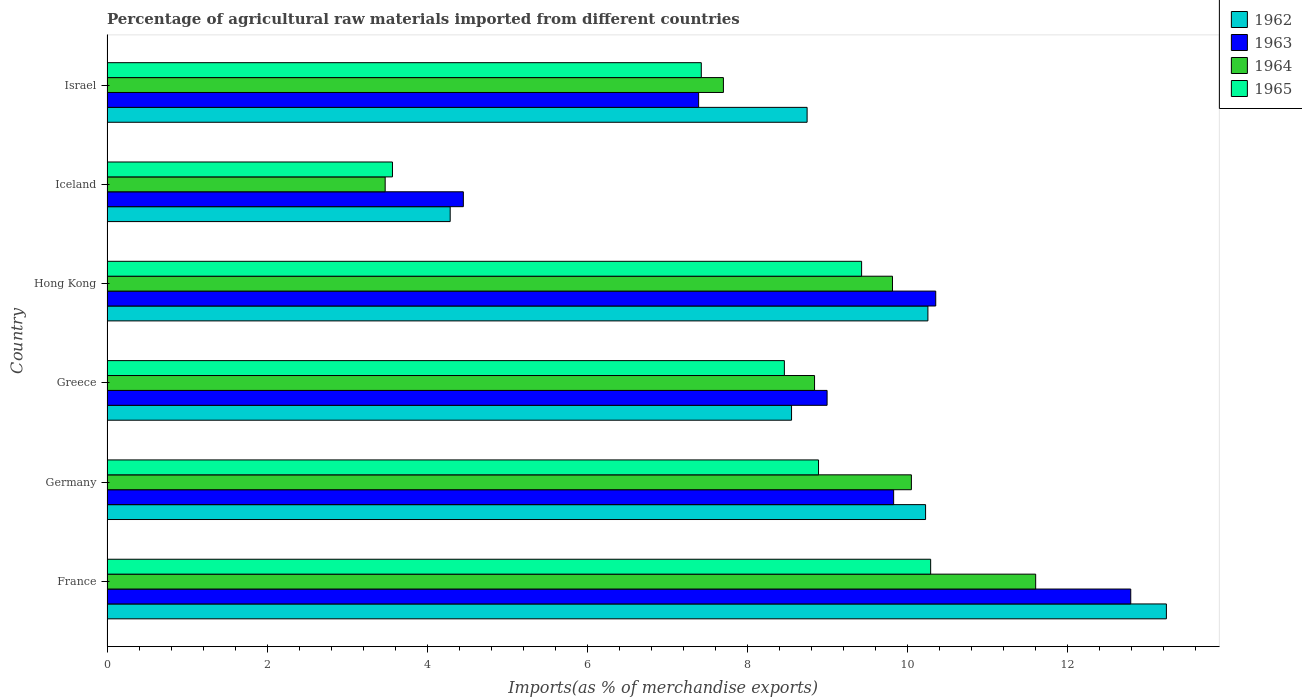How many different coloured bars are there?
Keep it short and to the point. 4. How many groups of bars are there?
Give a very brief answer. 6. Are the number of bars on each tick of the Y-axis equal?
Ensure brevity in your answer.  Yes. How many bars are there on the 4th tick from the top?
Offer a very short reply. 4. How many bars are there on the 5th tick from the bottom?
Provide a succinct answer. 4. What is the label of the 4th group of bars from the top?
Give a very brief answer. Greece. In how many cases, is the number of bars for a given country not equal to the number of legend labels?
Make the answer very short. 0. What is the percentage of imports to different countries in 1965 in Hong Kong?
Give a very brief answer. 9.43. Across all countries, what is the maximum percentage of imports to different countries in 1962?
Ensure brevity in your answer.  13.24. Across all countries, what is the minimum percentage of imports to different countries in 1962?
Offer a very short reply. 4.29. What is the total percentage of imports to different countries in 1963 in the graph?
Offer a very short reply. 53.81. What is the difference between the percentage of imports to different countries in 1963 in Hong Kong and that in Iceland?
Offer a very short reply. 5.9. What is the difference between the percentage of imports to different countries in 1965 in Greece and the percentage of imports to different countries in 1963 in Hong Kong?
Ensure brevity in your answer.  -1.89. What is the average percentage of imports to different countries in 1964 per country?
Your response must be concise. 8.58. What is the difference between the percentage of imports to different countries in 1963 and percentage of imports to different countries in 1965 in Hong Kong?
Provide a succinct answer. 0.93. In how many countries, is the percentage of imports to different countries in 1964 greater than 10 %?
Your response must be concise. 2. What is the ratio of the percentage of imports to different countries in 1963 in Germany to that in Israel?
Keep it short and to the point. 1.33. Is the percentage of imports to different countries in 1964 in Greece less than that in Iceland?
Ensure brevity in your answer.  No. What is the difference between the highest and the second highest percentage of imports to different countries in 1964?
Offer a very short reply. 1.55. What is the difference between the highest and the lowest percentage of imports to different countries in 1963?
Your answer should be very brief. 8.34. Is the sum of the percentage of imports to different countries in 1962 in Greece and Israel greater than the maximum percentage of imports to different countries in 1964 across all countries?
Your answer should be compact. Yes. Is it the case that in every country, the sum of the percentage of imports to different countries in 1963 and percentage of imports to different countries in 1965 is greater than the sum of percentage of imports to different countries in 1964 and percentage of imports to different countries in 1962?
Offer a terse response. No. What does the 3rd bar from the bottom in Israel represents?
Make the answer very short. 1964. How many countries are there in the graph?
Offer a very short reply. 6. Does the graph contain any zero values?
Your answer should be compact. No. Where does the legend appear in the graph?
Offer a terse response. Top right. How many legend labels are there?
Your answer should be compact. 4. How are the legend labels stacked?
Provide a succinct answer. Vertical. What is the title of the graph?
Your answer should be compact. Percentage of agricultural raw materials imported from different countries. What is the label or title of the X-axis?
Provide a short and direct response. Imports(as % of merchandise exports). What is the Imports(as % of merchandise exports) of 1962 in France?
Your answer should be compact. 13.24. What is the Imports(as % of merchandise exports) of 1963 in France?
Offer a very short reply. 12.79. What is the Imports(as % of merchandise exports) of 1964 in France?
Offer a terse response. 11.6. What is the Imports(as % of merchandise exports) of 1965 in France?
Ensure brevity in your answer.  10.29. What is the Imports(as % of merchandise exports) in 1962 in Germany?
Your response must be concise. 10.23. What is the Imports(as % of merchandise exports) of 1963 in Germany?
Your answer should be compact. 9.83. What is the Imports(as % of merchandise exports) in 1964 in Germany?
Offer a very short reply. 10.05. What is the Imports(as % of merchandise exports) of 1965 in Germany?
Make the answer very short. 8.89. What is the Imports(as % of merchandise exports) of 1962 in Greece?
Offer a terse response. 8.55. What is the Imports(as % of merchandise exports) in 1963 in Greece?
Provide a short and direct response. 9. What is the Imports(as % of merchandise exports) in 1964 in Greece?
Give a very brief answer. 8.84. What is the Imports(as % of merchandise exports) of 1965 in Greece?
Provide a short and direct response. 8.46. What is the Imports(as % of merchandise exports) of 1962 in Hong Kong?
Offer a very short reply. 10.26. What is the Imports(as % of merchandise exports) of 1963 in Hong Kong?
Ensure brevity in your answer.  10.35. What is the Imports(as % of merchandise exports) of 1964 in Hong Kong?
Your answer should be very brief. 9.81. What is the Imports(as % of merchandise exports) in 1965 in Hong Kong?
Provide a short and direct response. 9.43. What is the Imports(as % of merchandise exports) of 1962 in Iceland?
Give a very brief answer. 4.29. What is the Imports(as % of merchandise exports) of 1963 in Iceland?
Make the answer very short. 4.45. What is the Imports(as % of merchandise exports) of 1964 in Iceland?
Provide a succinct answer. 3.48. What is the Imports(as % of merchandise exports) of 1965 in Iceland?
Your answer should be compact. 3.57. What is the Imports(as % of merchandise exports) in 1962 in Israel?
Provide a succinct answer. 8.75. What is the Imports(as % of merchandise exports) in 1963 in Israel?
Ensure brevity in your answer.  7.39. What is the Imports(as % of merchandise exports) of 1964 in Israel?
Your answer should be very brief. 7.7. What is the Imports(as % of merchandise exports) of 1965 in Israel?
Offer a very short reply. 7.42. Across all countries, what is the maximum Imports(as % of merchandise exports) in 1962?
Provide a short and direct response. 13.24. Across all countries, what is the maximum Imports(as % of merchandise exports) in 1963?
Offer a terse response. 12.79. Across all countries, what is the maximum Imports(as % of merchandise exports) of 1964?
Offer a very short reply. 11.6. Across all countries, what is the maximum Imports(as % of merchandise exports) of 1965?
Offer a terse response. 10.29. Across all countries, what is the minimum Imports(as % of merchandise exports) of 1962?
Keep it short and to the point. 4.29. Across all countries, what is the minimum Imports(as % of merchandise exports) in 1963?
Your answer should be compact. 4.45. Across all countries, what is the minimum Imports(as % of merchandise exports) of 1964?
Make the answer very short. 3.48. Across all countries, what is the minimum Imports(as % of merchandise exports) of 1965?
Provide a succinct answer. 3.57. What is the total Imports(as % of merchandise exports) of 1962 in the graph?
Offer a very short reply. 55.3. What is the total Imports(as % of merchandise exports) in 1963 in the graph?
Ensure brevity in your answer.  53.81. What is the total Imports(as % of merchandise exports) in 1964 in the graph?
Your response must be concise. 51.48. What is the total Imports(as % of merchandise exports) in 1965 in the graph?
Your answer should be compact. 48.06. What is the difference between the Imports(as % of merchandise exports) in 1962 in France and that in Germany?
Make the answer very short. 3.01. What is the difference between the Imports(as % of merchandise exports) of 1963 in France and that in Germany?
Keep it short and to the point. 2.96. What is the difference between the Imports(as % of merchandise exports) of 1964 in France and that in Germany?
Keep it short and to the point. 1.55. What is the difference between the Imports(as % of merchandise exports) of 1965 in France and that in Germany?
Your answer should be very brief. 1.4. What is the difference between the Imports(as % of merchandise exports) of 1962 in France and that in Greece?
Ensure brevity in your answer.  4.68. What is the difference between the Imports(as % of merchandise exports) in 1963 in France and that in Greece?
Keep it short and to the point. 3.79. What is the difference between the Imports(as % of merchandise exports) in 1964 in France and that in Greece?
Provide a short and direct response. 2.76. What is the difference between the Imports(as % of merchandise exports) in 1965 in France and that in Greece?
Offer a very short reply. 1.83. What is the difference between the Imports(as % of merchandise exports) of 1962 in France and that in Hong Kong?
Your answer should be very brief. 2.98. What is the difference between the Imports(as % of merchandise exports) of 1963 in France and that in Hong Kong?
Keep it short and to the point. 2.44. What is the difference between the Imports(as % of merchandise exports) of 1964 in France and that in Hong Kong?
Offer a very short reply. 1.79. What is the difference between the Imports(as % of merchandise exports) of 1965 in France and that in Hong Kong?
Your response must be concise. 0.86. What is the difference between the Imports(as % of merchandise exports) of 1962 in France and that in Iceland?
Ensure brevity in your answer.  8.95. What is the difference between the Imports(as % of merchandise exports) of 1963 in France and that in Iceland?
Ensure brevity in your answer.  8.34. What is the difference between the Imports(as % of merchandise exports) in 1964 in France and that in Iceland?
Your answer should be compact. 8.13. What is the difference between the Imports(as % of merchandise exports) of 1965 in France and that in Iceland?
Your answer should be very brief. 6.72. What is the difference between the Imports(as % of merchandise exports) of 1962 in France and that in Israel?
Provide a succinct answer. 4.49. What is the difference between the Imports(as % of merchandise exports) of 1963 in France and that in Israel?
Give a very brief answer. 5.4. What is the difference between the Imports(as % of merchandise exports) of 1964 in France and that in Israel?
Your response must be concise. 3.9. What is the difference between the Imports(as % of merchandise exports) in 1965 in France and that in Israel?
Give a very brief answer. 2.87. What is the difference between the Imports(as % of merchandise exports) in 1962 in Germany and that in Greece?
Keep it short and to the point. 1.67. What is the difference between the Imports(as % of merchandise exports) in 1963 in Germany and that in Greece?
Keep it short and to the point. 0.83. What is the difference between the Imports(as % of merchandise exports) in 1964 in Germany and that in Greece?
Offer a very short reply. 1.21. What is the difference between the Imports(as % of merchandise exports) of 1965 in Germany and that in Greece?
Ensure brevity in your answer.  0.43. What is the difference between the Imports(as % of merchandise exports) in 1962 in Germany and that in Hong Kong?
Your response must be concise. -0.03. What is the difference between the Imports(as % of merchandise exports) of 1963 in Germany and that in Hong Kong?
Ensure brevity in your answer.  -0.53. What is the difference between the Imports(as % of merchandise exports) in 1964 in Germany and that in Hong Kong?
Your response must be concise. 0.24. What is the difference between the Imports(as % of merchandise exports) in 1965 in Germany and that in Hong Kong?
Provide a short and direct response. -0.54. What is the difference between the Imports(as % of merchandise exports) of 1962 in Germany and that in Iceland?
Offer a terse response. 5.94. What is the difference between the Imports(as % of merchandise exports) in 1963 in Germany and that in Iceland?
Keep it short and to the point. 5.38. What is the difference between the Imports(as % of merchandise exports) of 1964 in Germany and that in Iceland?
Offer a very short reply. 6.57. What is the difference between the Imports(as % of merchandise exports) of 1965 in Germany and that in Iceland?
Ensure brevity in your answer.  5.32. What is the difference between the Imports(as % of merchandise exports) of 1962 in Germany and that in Israel?
Provide a succinct answer. 1.48. What is the difference between the Imports(as % of merchandise exports) of 1963 in Germany and that in Israel?
Your answer should be compact. 2.44. What is the difference between the Imports(as % of merchandise exports) of 1964 in Germany and that in Israel?
Your answer should be very brief. 2.35. What is the difference between the Imports(as % of merchandise exports) of 1965 in Germany and that in Israel?
Your answer should be very brief. 1.46. What is the difference between the Imports(as % of merchandise exports) of 1962 in Greece and that in Hong Kong?
Ensure brevity in your answer.  -1.7. What is the difference between the Imports(as % of merchandise exports) of 1963 in Greece and that in Hong Kong?
Keep it short and to the point. -1.36. What is the difference between the Imports(as % of merchandise exports) in 1964 in Greece and that in Hong Kong?
Keep it short and to the point. -0.97. What is the difference between the Imports(as % of merchandise exports) of 1965 in Greece and that in Hong Kong?
Offer a terse response. -0.96. What is the difference between the Imports(as % of merchandise exports) in 1962 in Greece and that in Iceland?
Provide a succinct answer. 4.26. What is the difference between the Imports(as % of merchandise exports) of 1963 in Greece and that in Iceland?
Offer a terse response. 4.54. What is the difference between the Imports(as % of merchandise exports) in 1964 in Greece and that in Iceland?
Give a very brief answer. 5.36. What is the difference between the Imports(as % of merchandise exports) of 1965 in Greece and that in Iceland?
Your response must be concise. 4.9. What is the difference between the Imports(as % of merchandise exports) of 1962 in Greece and that in Israel?
Offer a very short reply. -0.19. What is the difference between the Imports(as % of merchandise exports) of 1963 in Greece and that in Israel?
Your response must be concise. 1.6. What is the difference between the Imports(as % of merchandise exports) in 1964 in Greece and that in Israel?
Make the answer very short. 1.14. What is the difference between the Imports(as % of merchandise exports) in 1965 in Greece and that in Israel?
Provide a succinct answer. 1.04. What is the difference between the Imports(as % of merchandise exports) in 1962 in Hong Kong and that in Iceland?
Give a very brief answer. 5.97. What is the difference between the Imports(as % of merchandise exports) in 1963 in Hong Kong and that in Iceland?
Offer a terse response. 5.9. What is the difference between the Imports(as % of merchandise exports) in 1964 in Hong Kong and that in Iceland?
Make the answer very short. 6.34. What is the difference between the Imports(as % of merchandise exports) in 1965 in Hong Kong and that in Iceland?
Make the answer very short. 5.86. What is the difference between the Imports(as % of merchandise exports) of 1962 in Hong Kong and that in Israel?
Your answer should be very brief. 1.51. What is the difference between the Imports(as % of merchandise exports) in 1963 in Hong Kong and that in Israel?
Offer a terse response. 2.96. What is the difference between the Imports(as % of merchandise exports) of 1964 in Hong Kong and that in Israel?
Your answer should be compact. 2.11. What is the difference between the Imports(as % of merchandise exports) in 1965 in Hong Kong and that in Israel?
Your answer should be very brief. 2. What is the difference between the Imports(as % of merchandise exports) in 1962 in Iceland and that in Israel?
Offer a very short reply. -4.46. What is the difference between the Imports(as % of merchandise exports) of 1963 in Iceland and that in Israel?
Offer a very short reply. -2.94. What is the difference between the Imports(as % of merchandise exports) of 1964 in Iceland and that in Israel?
Your answer should be very brief. -4.23. What is the difference between the Imports(as % of merchandise exports) of 1965 in Iceland and that in Israel?
Keep it short and to the point. -3.86. What is the difference between the Imports(as % of merchandise exports) of 1962 in France and the Imports(as % of merchandise exports) of 1963 in Germany?
Keep it short and to the point. 3.41. What is the difference between the Imports(as % of merchandise exports) of 1962 in France and the Imports(as % of merchandise exports) of 1964 in Germany?
Your answer should be very brief. 3.19. What is the difference between the Imports(as % of merchandise exports) of 1962 in France and the Imports(as % of merchandise exports) of 1965 in Germany?
Give a very brief answer. 4.35. What is the difference between the Imports(as % of merchandise exports) in 1963 in France and the Imports(as % of merchandise exports) in 1964 in Germany?
Your answer should be very brief. 2.74. What is the difference between the Imports(as % of merchandise exports) in 1963 in France and the Imports(as % of merchandise exports) in 1965 in Germany?
Offer a terse response. 3.9. What is the difference between the Imports(as % of merchandise exports) of 1964 in France and the Imports(as % of merchandise exports) of 1965 in Germany?
Give a very brief answer. 2.71. What is the difference between the Imports(as % of merchandise exports) of 1962 in France and the Imports(as % of merchandise exports) of 1963 in Greece?
Ensure brevity in your answer.  4.24. What is the difference between the Imports(as % of merchandise exports) in 1962 in France and the Imports(as % of merchandise exports) in 1964 in Greece?
Provide a short and direct response. 4.4. What is the difference between the Imports(as % of merchandise exports) of 1962 in France and the Imports(as % of merchandise exports) of 1965 in Greece?
Offer a very short reply. 4.77. What is the difference between the Imports(as % of merchandise exports) of 1963 in France and the Imports(as % of merchandise exports) of 1964 in Greece?
Keep it short and to the point. 3.95. What is the difference between the Imports(as % of merchandise exports) of 1963 in France and the Imports(as % of merchandise exports) of 1965 in Greece?
Give a very brief answer. 4.33. What is the difference between the Imports(as % of merchandise exports) in 1964 in France and the Imports(as % of merchandise exports) in 1965 in Greece?
Provide a short and direct response. 3.14. What is the difference between the Imports(as % of merchandise exports) in 1962 in France and the Imports(as % of merchandise exports) in 1963 in Hong Kong?
Your response must be concise. 2.88. What is the difference between the Imports(as % of merchandise exports) of 1962 in France and the Imports(as % of merchandise exports) of 1964 in Hong Kong?
Provide a short and direct response. 3.42. What is the difference between the Imports(as % of merchandise exports) of 1962 in France and the Imports(as % of merchandise exports) of 1965 in Hong Kong?
Provide a short and direct response. 3.81. What is the difference between the Imports(as % of merchandise exports) in 1963 in France and the Imports(as % of merchandise exports) in 1964 in Hong Kong?
Make the answer very short. 2.98. What is the difference between the Imports(as % of merchandise exports) in 1963 in France and the Imports(as % of merchandise exports) in 1965 in Hong Kong?
Your answer should be compact. 3.36. What is the difference between the Imports(as % of merchandise exports) of 1964 in France and the Imports(as % of merchandise exports) of 1965 in Hong Kong?
Your answer should be very brief. 2.17. What is the difference between the Imports(as % of merchandise exports) of 1962 in France and the Imports(as % of merchandise exports) of 1963 in Iceland?
Your answer should be compact. 8.78. What is the difference between the Imports(as % of merchandise exports) in 1962 in France and the Imports(as % of merchandise exports) in 1964 in Iceland?
Ensure brevity in your answer.  9.76. What is the difference between the Imports(as % of merchandise exports) of 1962 in France and the Imports(as % of merchandise exports) of 1965 in Iceland?
Your response must be concise. 9.67. What is the difference between the Imports(as % of merchandise exports) of 1963 in France and the Imports(as % of merchandise exports) of 1964 in Iceland?
Provide a succinct answer. 9.31. What is the difference between the Imports(as % of merchandise exports) in 1963 in France and the Imports(as % of merchandise exports) in 1965 in Iceland?
Your response must be concise. 9.22. What is the difference between the Imports(as % of merchandise exports) of 1964 in France and the Imports(as % of merchandise exports) of 1965 in Iceland?
Your answer should be very brief. 8.04. What is the difference between the Imports(as % of merchandise exports) in 1962 in France and the Imports(as % of merchandise exports) in 1963 in Israel?
Provide a succinct answer. 5.84. What is the difference between the Imports(as % of merchandise exports) of 1962 in France and the Imports(as % of merchandise exports) of 1964 in Israel?
Your answer should be very brief. 5.53. What is the difference between the Imports(as % of merchandise exports) in 1962 in France and the Imports(as % of merchandise exports) in 1965 in Israel?
Provide a short and direct response. 5.81. What is the difference between the Imports(as % of merchandise exports) of 1963 in France and the Imports(as % of merchandise exports) of 1964 in Israel?
Offer a very short reply. 5.09. What is the difference between the Imports(as % of merchandise exports) of 1963 in France and the Imports(as % of merchandise exports) of 1965 in Israel?
Keep it short and to the point. 5.37. What is the difference between the Imports(as % of merchandise exports) in 1964 in France and the Imports(as % of merchandise exports) in 1965 in Israel?
Offer a terse response. 4.18. What is the difference between the Imports(as % of merchandise exports) of 1962 in Germany and the Imports(as % of merchandise exports) of 1963 in Greece?
Make the answer very short. 1.23. What is the difference between the Imports(as % of merchandise exports) of 1962 in Germany and the Imports(as % of merchandise exports) of 1964 in Greece?
Keep it short and to the point. 1.39. What is the difference between the Imports(as % of merchandise exports) of 1962 in Germany and the Imports(as % of merchandise exports) of 1965 in Greece?
Make the answer very short. 1.76. What is the difference between the Imports(as % of merchandise exports) of 1963 in Germany and the Imports(as % of merchandise exports) of 1964 in Greece?
Ensure brevity in your answer.  0.99. What is the difference between the Imports(as % of merchandise exports) in 1963 in Germany and the Imports(as % of merchandise exports) in 1965 in Greece?
Provide a short and direct response. 1.36. What is the difference between the Imports(as % of merchandise exports) in 1964 in Germany and the Imports(as % of merchandise exports) in 1965 in Greece?
Your answer should be compact. 1.59. What is the difference between the Imports(as % of merchandise exports) in 1962 in Germany and the Imports(as % of merchandise exports) in 1963 in Hong Kong?
Ensure brevity in your answer.  -0.13. What is the difference between the Imports(as % of merchandise exports) in 1962 in Germany and the Imports(as % of merchandise exports) in 1964 in Hong Kong?
Give a very brief answer. 0.41. What is the difference between the Imports(as % of merchandise exports) in 1962 in Germany and the Imports(as % of merchandise exports) in 1965 in Hong Kong?
Ensure brevity in your answer.  0.8. What is the difference between the Imports(as % of merchandise exports) in 1963 in Germany and the Imports(as % of merchandise exports) in 1964 in Hong Kong?
Your response must be concise. 0.01. What is the difference between the Imports(as % of merchandise exports) of 1963 in Germany and the Imports(as % of merchandise exports) of 1965 in Hong Kong?
Ensure brevity in your answer.  0.4. What is the difference between the Imports(as % of merchandise exports) in 1964 in Germany and the Imports(as % of merchandise exports) in 1965 in Hong Kong?
Offer a terse response. 0.62. What is the difference between the Imports(as % of merchandise exports) of 1962 in Germany and the Imports(as % of merchandise exports) of 1963 in Iceland?
Your answer should be very brief. 5.77. What is the difference between the Imports(as % of merchandise exports) in 1962 in Germany and the Imports(as % of merchandise exports) in 1964 in Iceland?
Your response must be concise. 6.75. What is the difference between the Imports(as % of merchandise exports) in 1962 in Germany and the Imports(as % of merchandise exports) in 1965 in Iceland?
Ensure brevity in your answer.  6.66. What is the difference between the Imports(as % of merchandise exports) of 1963 in Germany and the Imports(as % of merchandise exports) of 1964 in Iceland?
Offer a very short reply. 6.35. What is the difference between the Imports(as % of merchandise exports) in 1963 in Germany and the Imports(as % of merchandise exports) in 1965 in Iceland?
Your response must be concise. 6.26. What is the difference between the Imports(as % of merchandise exports) in 1964 in Germany and the Imports(as % of merchandise exports) in 1965 in Iceland?
Your response must be concise. 6.48. What is the difference between the Imports(as % of merchandise exports) in 1962 in Germany and the Imports(as % of merchandise exports) in 1963 in Israel?
Provide a succinct answer. 2.84. What is the difference between the Imports(as % of merchandise exports) in 1962 in Germany and the Imports(as % of merchandise exports) in 1964 in Israel?
Offer a very short reply. 2.53. What is the difference between the Imports(as % of merchandise exports) in 1962 in Germany and the Imports(as % of merchandise exports) in 1965 in Israel?
Offer a very short reply. 2.8. What is the difference between the Imports(as % of merchandise exports) in 1963 in Germany and the Imports(as % of merchandise exports) in 1964 in Israel?
Make the answer very short. 2.13. What is the difference between the Imports(as % of merchandise exports) of 1963 in Germany and the Imports(as % of merchandise exports) of 1965 in Israel?
Offer a very short reply. 2.4. What is the difference between the Imports(as % of merchandise exports) in 1964 in Germany and the Imports(as % of merchandise exports) in 1965 in Israel?
Give a very brief answer. 2.62. What is the difference between the Imports(as % of merchandise exports) in 1962 in Greece and the Imports(as % of merchandise exports) in 1963 in Hong Kong?
Ensure brevity in your answer.  -1.8. What is the difference between the Imports(as % of merchandise exports) in 1962 in Greece and the Imports(as % of merchandise exports) in 1964 in Hong Kong?
Your response must be concise. -1.26. What is the difference between the Imports(as % of merchandise exports) of 1962 in Greece and the Imports(as % of merchandise exports) of 1965 in Hong Kong?
Your answer should be compact. -0.88. What is the difference between the Imports(as % of merchandise exports) of 1963 in Greece and the Imports(as % of merchandise exports) of 1964 in Hong Kong?
Provide a short and direct response. -0.82. What is the difference between the Imports(as % of merchandise exports) of 1963 in Greece and the Imports(as % of merchandise exports) of 1965 in Hong Kong?
Ensure brevity in your answer.  -0.43. What is the difference between the Imports(as % of merchandise exports) in 1964 in Greece and the Imports(as % of merchandise exports) in 1965 in Hong Kong?
Provide a short and direct response. -0.59. What is the difference between the Imports(as % of merchandise exports) in 1962 in Greece and the Imports(as % of merchandise exports) in 1963 in Iceland?
Provide a short and direct response. 4.1. What is the difference between the Imports(as % of merchandise exports) in 1962 in Greece and the Imports(as % of merchandise exports) in 1964 in Iceland?
Provide a short and direct response. 5.08. What is the difference between the Imports(as % of merchandise exports) in 1962 in Greece and the Imports(as % of merchandise exports) in 1965 in Iceland?
Your answer should be compact. 4.99. What is the difference between the Imports(as % of merchandise exports) of 1963 in Greece and the Imports(as % of merchandise exports) of 1964 in Iceland?
Your answer should be compact. 5.52. What is the difference between the Imports(as % of merchandise exports) in 1963 in Greece and the Imports(as % of merchandise exports) in 1965 in Iceland?
Keep it short and to the point. 5.43. What is the difference between the Imports(as % of merchandise exports) of 1964 in Greece and the Imports(as % of merchandise exports) of 1965 in Iceland?
Offer a terse response. 5.27. What is the difference between the Imports(as % of merchandise exports) in 1962 in Greece and the Imports(as % of merchandise exports) in 1963 in Israel?
Offer a very short reply. 1.16. What is the difference between the Imports(as % of merchandise exports) of 1962 in Greece and the Imports(as % of merchandise exports) of 1964 in Israel?
Offer a terse response. 0.85. What is the difference between the Imports(as % of merchandise exports) in 1962 in Greece and the Imports(as % of merchandise exports) in 1965 in Israel?
Make the answer very short. 1.13. What is the difference between the Imports(as % of merchandise exports) in 1963 in Greece and the Imports(as % of merchandise exports) in 1964 in Israel?
Offer a very short reply. 1.3. What is the difference between the Imports(as % of merchandise exports) in 1963 in Greece and the Imports(as % of merchandise exports) in 1965 in Israel?
Keep it short and to the point. 1.57. What is the difference between the Imports(as % of merchandise exports) of 1964 in Greece and the Imports(as % of merchandise exports) of 1965 in Israel?
Provide a succinct answer. 1.42. What is the difference between the Imports(as % of merchandise exports) of 1962 in Hong Kong and the Imports(as % of merchandise exports) of 1963 in Iceland?
Your response must be concise. 5.8. What is the difference between the Imports(as % of merchandise exports) in 1962 in Hong Kong and the Imports(as % of merchandise exports) in 1964 in Iceland?
Ensure brevity in your answer.  6.78. What is the difference between the Imports(as % of merchandise exports) of 1962 in Hong Kong and the Imports(as % of merchandise exports) of 1965 in Iceland?
Make the answer very short. 6.69. What is the difference between the Imports(as % of merchandise exports) of 1963 in Hong Kong and the Imports(as % of merchandise exports) of 1964 in Iceland?
Offer a terse response. 6.88. What is the difference between the Imports(as % of merchandise exports) of 1963 in Hong Kong and the Imports(as % of merchandise exports) of 1965 in Iceland?
Give a very brief answer. 6.79. What is the difference between the Imports(as % of merchandise exports) of 1964 in Hong Kong and the Imports(as % of merchandise exports) of 1965 in Iceland?
Your answer should be very brief. 6.25. What is the difference between the Imports(as % of merchandise exports) of 1962 in Hong Kong and the Imports(as % of merchandise exports) of 1963 in Israel?
Your response must be concise. 2.86. What is the difference between the Imports(as % of merchandise exports) of 1962 in Hong Kong and the Imports(as % of merchandise exports) of 1964 in Israel?
Keep it short and to the point. 2.55. What is the difference between the Imports(as % of merchandise exports) of 1962 in Hong Kong and the Imports(as % of merchandise exports) of 1965 in Israel?
Offer a terse response. 2.83. What is the difference between the Imports(as % of merchandise exports) of 1963 in Hong Kong and the Imports(as % of merchandise exports) of 1964 in Israel?
Offer a terse response. 2.65. What is the difference between the Imports(as % of merchandise exports) of 1963 in Hong Kong and the Imports(as % of merchandise exports) of 1965 in Israel?
Your response must be concise. 2.93. What is the difference between the Imports(as % of merchandise exports) in 1964 in Hong Kong and the Imports(as % of merchandise exports) in 1965 in Israel?
Ensure brevity in your answer.  2.39. What is the difference between the Imports(as % of merchandise exports) in 1962 in Iceland and the Imports(as % of merchandise exports) in 1963 in Israel?
Keep it short and to the point. -3.1. What is the difference between the Imports(as % of merchandise exports) of 1962 in Iceland and the Imports(as % of merchandise exports) of 1964 in Israel?
Provide a short and direct response. -3.41. What is the difference between the Imports(as % of merchandise exports) in 1962 in Iceland and the Imports(as % of merchandise exports) in 1965 in Israel?
Your response must be concise. -3.14. What is the difference between the Imports(as % of merchandise exports) in 1963 in Iceland and the Imports(as % of merchandise exports) in 1964 in Israel?
Your answer should be very brief. -3.25. What is the difference between the Imports(as % of merchandise exports) of 1963 in Iceland and the Imports(as % of merchandise exports) of 1965 in Israel?
Give a very brief answer. -2.97. What is the difference between the Imports(as % of merchandise exports) in 1964 in Iceland and the Imports(as % of merchandise exports) in 1965 in Israel?
Make the answer very short. -3.95. What is the average Imports(as % of merchandise exports) in 1962 per country?
Keep it short and to the point. 9.22. What is the average Imports(as % of merchandise exports) in 1963 per country?
Your answer should be compact. 8.97. What is the average Imports(as % of merchandise exports) of 1964 per country?
Give a very brief answer. 8.58. What is the average Imports(as % of merchandise exports) in 1965 per country?
Provide a succinct answer. 8.01. What is the difference between the Imports(as % of merchandise exports) in 1962 and Imports(as % of merchandise exports) in 1963 in France?
Your response must be concise. 0.45. What is the difference between the Imports(as % of merchandise exports) in 1962 and Imports(as % of merchandise exports) in 1964 in France?
Offer a very short reply. 1.63. What is the difference between the Imports(as % of merchandise exports) in 1962 and Imports(as % of merchandise exports) in 1965 in France?
Provide a succinct answer. 2.95. What is the difference between the Imports(as % of merchandise exports) in 1963 and Imports(as % of merchandise exports) in 1964 in France?
Provide a succinct answer. 1.19. What is the difference between the Imports(as % of merchandise exports) of 1963 and Imports(as % of merchandise exports) of 1965 in France?
Your answer should be compact. 2.5. What is the difference between the Imports(as % of merchandise exports) in 1964 and Imports(as % of merchandise exports) in 1965 in France?
Your response must be concise. 1.31. What is the difference between the Imports(as % of merchandise exports) in 1962 and Imports(as % of merchandise exports) in 1963 in Germany?
Provide a short and direct response. 0.4. What is the difference between the Imports(as % of merchandise exports) of 1962 and Imports(as % of merchandise exports) of 1964 in Germany?
Provide a short and direct response. 0.18. What is the difference between the Imports(as % of merchandise exports) of 1962 and Imports(as % of merchandise exports) of 1965 in Germany?
Keep it short and to the point. 1.34. What is the difference between the Imports(as % of merchandise exports) in 1963 and Imports(as % of merchandise exports) in 1964 in Germany?
Your answer should be compact. -0.22. What is the difference between the Imports(as % of merchandise exports) of 1963 and Imports(as % of merchandise exports) of 1965 in Germany?
Offer a terse response. 0.94. What is the difference between the Imports(as % of merchandise exports) of 1964 and Imports(as % of merchandise exports) of 1965 in Germany?
Keep it short and to the point. 1.16. What is the difference between the Imports(as % of merchandise exports) in 1962 and Imports(as % of merchandise exports) in 1963 in Greece?
Your response must be concise. -0.44. What is the difference between the Imports(as % of merchandise exports) in 1962 and Imports(as % of merchandise exports) in 1964 in Greece?
Give a very brief answer. -0.29. What is the difference between the Imports(as % of merchandise exports) of 1962 and Imports(as % of merchandise exports) of 1965 in Greece?
Ensure brevity in your answer.  0.09. What is the difference between the Imports(as % of merchandise exports) of 1963 and Imports(as % of merchandise exports) of 1964 in Greece?
Keep it short and to the point. 0.16. What is the difference between the Imports(as % of merchandise exports) of 1963 and Imports(as % of merchandise exports) of 1965 in Greece?
Offer a terse response. 0.53. What is the difference between the Imports(as % of merchandise exports) of 1964 and Imports(as % of merchandise exports) of 1965 in Greece?
Your answer should be compact. 0.38. What is the difference between the Imports(as % of merchandise exports) in 1962 and Imports(as % of merchandise exports) in 1963 in Hong Kong?
Provide a short and direct response. -0.1. What is the difference between the Imports(as % of merchandise exports) in 1962 and Imports(as % of merchandise exports) in 1964 in Hong Kong?
Your response must be concise. 0.44. What is the difference between the Imports(as % of merchandise exports) of 1962 and Imports(as % of merchandise exports) of 1965 in Hong Kong?
Your answer should be very brief. 0.83. What is the difference between the Imports(as % of merchandise exports) of 1963 and Imports(as % of merchandise exports) of 1964 in Hong Kong?
Offer a very short reply. 0.54. What is the difference between the Imports(as % of merchandise exports) of 1963 and Imports(as % of merchandise exports) of 1965 in Hong Kong?
Your response must be concise. 0.93. What is the difference between the Imports(as % of merchandise exports) in 1964 and Imports(as % of merchandise exports) in 1965 in Hong Kong?
Offer a terse response. 0.39. What is the difference between the Imports(as % of merchandise exports) in 1962 and Imports(as % of merchandise exports) in 1963 in Iceland?
Provide a succinct answer. -0.16. What is the difference between the Imports(as % of merchandise exports) in 1962 and Imports(as % of merchandise exports) in 1964 in Iceland?
Provide a short and direct response. 0.81. What is the difference between the Imports(as % of merchandise exports) in 1962 and Imports(as % of merchandise exports) in 1965 in Iceland?
Your answer should be compact. 0.72. What is the difference between the Imports(as % of merchandise exports) in 1963 and Imports(as % of merchandise exports) in 1964 in Iceland?
Provide a succinct answer. 0.98. What is the difference between the Imports(as % of merchandise exports) of 1963 and Imports(as % of merchandise exports) of 1965 in Iceland?
Ensure brevity in your answer.  0.89. What is the difference between the Imports(as % of merchandise exports) in 1964 and Imports(as % of merchandise exports) in 1965 in Iceland?
Keep it short and to the point. -0.09. What is the difference between the Imports(as % of merchandise exports) of 1962 and Imports(as % of merchandise exports) of 1963 in Israel?
Keep it short and to the point. 1.36. What is the difference between the Imports(as % of merchandise exports) of 1962 and Imports(as % of merchandise exports) of 1964 in Israel?
Your answer should be very brief. 1.05. What is the difference between the Imports(as % of merchandise exports) of 1962 and Imports(as % of merchandise exports) of 1965 in Israel?
Give a very brief answer. 1.32. What is the difference between the Imports(as % of merchandise exports) of 1963 and Imports(as % of merchandise exports) of 1964 in Israel?
Your answer should be compact. -0.31. What is the difference between the Imports(as % of merchandise exports) of 1963 and Imports(as % of merchandise exports) of 1965 in Israel?
Provide a succinct answer. -0.03. What is the difference between the Imports(as % of merchandise exports) of 1964 and Imports(as % of merchandise exports) of 1965 in Israel?
Offer a very short reply. 0.28. What is the ratio of the Imports(as % of merchandise exports) in 1962 in France to that in Germany?
Offer a very short reply. 1.29. What is the ratio of the Imports(as % of merchandise exports) in 1963 in France to that in Germany?
Your answer should be very brief. 1.3. What is the ratio of the Imports(as % of merchandise exports) in 1964 in France to that in Germany?
Offer a very short reply. 1.15. What is the ratio of the Imports(as % of merchandise exports) of 1965 in France to that in Germany?
Keep it short and to the point. 1.16. What is the ratio of the Imports(as % of merchandise exports) in 1962 in France to that in Greece?
Provide a succinct answer. 1.55. What is the ratio of the Imports(as % of merchandise exports) of 1963 in France to that in Greece?
Your answer should be very brief. 1.42. What is the ratio of the Imports(as % of merchandise exports) in 1964 in France to that in Greece?
Your answer should be compact. 1.31. What is the ratio of the Imports(as % of merchandise exports) in 1965 in France to that in Greece?
Make the answer very short. 1.22. What is the ratio of the Imports(as % of merchandise exports) in 1962 in France to that in Hong Kong?
Ensure brevity in your answer.  1.29. What is the ratio of the Imports(as % of merchandise exports) of 1963 in France to that in Hong Kong?
Offer a very short reply. 1.24. What is the ratio of the Imports(as % of merchandise exports) in 1964 in France to that in Hong Kong?
Give a very brief answer. 1.18. What is the ratio of the Imports(as % of merchandise exports) in 1965 in France to that in Hong Kong?
Provide a short and direct response. 1.09. What is the ratio of the Imports(as % of merchandise exports) of 1962 in France to that in Iceland?
Your answer should be compact. 3.09. What is the ratio of the Imports(as % of merchandise exports) of 1963 in France to that in Iceland?
Provide a short and direct response. 2.87. What is the ratio of the Imports(as % of merchandise exports) of 1964 in France to that in Iceland?
Offer a very short reply. 3.34. What is the ratio of the Imports(as % of merchandise exports) in 1965 in France to that in Iceland?
Provide a succinct answer. 2.89. What is the ratio of the Imports(as % of merchandise exports) in 1962 in France to that in Israel?
Provide a succinct answer. 1.51. What is the ratio of the Imports(as % of merchandise exports) in 1963 in France to that in Israel?
Offer a very short reply. 1.73. What is the ratio of the Imports(as % of merchandise exports) of 1964 in France to that in Israel?
Keep it short and to the point. 1.51. What is the ratio of the Imports(as % of merchandise exports) of 1965 in France to that in Israel?
Offer a very short reply. 1.39. What is the ratio of the Imports(as % of merchandise exports) of 1962 in Germany to that in Greece?
Provide a succinct answer. 1.2. What is the ratio of the Imports(as % of merchandise exports) in 1963 in Germany to that in Greece?
Offer a terse response. 1.09. What is the ratio of the Imports(as % of merchandise exports) in 1964 in Germany to that in Greece?
Ensure brevity in your answer.  1.14. What is the ratio of the Imports(as % of merchandise exports) in 1965 in Germany to that in Greece?
Your response must be concise. 1.05. What is the ratio of the Imports(as % of merchandise exports) of 1963 in Germany to that in Hong Kong?
Your answer should be compact. 0.95. What is the ratio of the Imports(as % of merchandise exports) of 1964 in Germany to that in Hong Kong?
Keep it short and to the point. 1.02. What is the ratio of the Imports(as % of merchandise exports) in 1965 in Germany to that in Hong Kong?
Your answer should be compact. 0.94. What is the ratio of the Imports(as % of merchandise exports) of 1962 in Germany to that in Iceland?
Provide a short and direct response. 2.39. What is the ratio of the Imports(as % of merchandise exports) of 1963 in Germany to that in Iceland?
Offer a terse response. 2.21. What is the ratio of the Imports(as % of merchandise exports) in 1964 in Germany to that in Iceland?
Keep it short and to the point. 2.89. What is the ratio of the Imports(as % of merchandise exports) of 1965 in Germany to that in Iceland?
Provide a succinct answer. 2.49. What is the ratio of the Imports(as % of merchandise exports) in 1962 in Germany to that in Israel?
Your answer should be very brief. 1.17. What is the ratio of the Imports(as % of merchandise exports) of 1963 in Germany to that in Israel?
Make the answer very short. 1.33. What is the ratio of the Imports(as % of merchandise exports) of 1964 in Germany to that in Israel?
Make the answer very short. 1.3. What is the ratio of the Imports(as % of merchandise exports) in 1965 in Germany to that in Israel?
Provide a short and direct response. 1.2. What is the ratio of the Imports(as % of merchandise exports) of 1962 in Greece to that in Hong Kong?
Make the answer very short. 0.83. What is the ratio of the Imports(as % of merchandise exports) of 1963 in Greece to that in Hong Kong?
Offer a very short reply. 0.87. What is the ratio of the Imports(as % of merchandise exports) of 1964 in Greece to that in Hong Kong?
Offer a very short reply. 0.9. What is the ratio of the Imports(as % of merchandise exports) in 1965 in Greece to that in Hong Kong?
Your answer should be very brief. 0.9. What is the ratio of the Imports(as % of merchandise exports) in 1962 in Greece to that in Iceland?
Make the answer very short. 1.99. What is the ratio of the Imports(as % of merchandise exports) in 1963 in Greece to that in Iceland?
Your response must be concise. 2.02. What is the ratio of the Imports(as % of merchandise exports) of 1964 in Greece to that in Iceland?
Offer a terse response. 2.54. What is the ratio of the Imports(as % of merchandise exports) in 1965 in Greece to that in Iceland?
Ensure brevity in your answer.  2.37. What is the ratio of the Imports(as % of merchandise exports) in 1962 in Greece to that in Israel?
Your answer should be very brief. 0.98. What is the ratio of the Imports(as % of merchandise exports) of 1963 in Greece to that in Israel?
Your answer should be compact. 1.22. What is the ratio of the Imports(as % of merchandise exports) in 1964 in Greece to that in Israel?
Offer a terse response. 1.15. What is the ratio of the Imports(as % of merchandise exports) of 1965 in Greece to that in Israel?
Offer a very short reply. 1.14. What is the ratio of the Imports(as % of merchandise exports) in 1962 in Hong Kong to that in Iceland?
Offer a terse response. 2.39. What is the ratio of the Imports(as % of merchandise exports) of 1963 in Hong Kong to that in Iceland?
Ensure brevity in your answer.  2.33. What is the ratio of the Imports(as % of merchandise exports) of 1964 in Hong Kong to that in Iceland?
Your answer should be compact. 2.82. What is the ratio of the Imports(as % of merchandise exports) in 1965 in Hong Kong to that in Iceland?
Your answer should be very brief. 2.64. What is the ratio of the Imports(as % of merchandise exports) of 1962 in Hong Kong to that in Israel?
Keep it short and to the point. 1.17. What is the ratio of the Imports(as % of merchandise exports) in 1963 in Hong Kong to that in Israel?
Your answer should be compact. 1.4. What is the ratio of the Imports(as % of merchandise exports) in 1964 in Hong Kong to that in Israel?
Provide a succinct answer. 1.27. What is the ratio of the Imports(as % of merchandise exports) in 1965 in Hong Kong to that in Israel?
Your answer should be very brief. 1.27. What is the ratio of the Imports(as % of merchandise exports) of 1962 in Iceland to that in Israel?
Your answer should be very brief. 0.49. What is the ratio of the Imports(as % of merchandise exports) in 1963 in Iceland to that in Israel?
Make the answer very short. 0.6. What is the ratio of the Imports(as % of merchandise exports) of 1964 in Iceland to that in Israel?
Provide a short and direct response. 0.45. What is the ratio of the Imports(as % of merchandise exports) of 1965 in Iceland to that in Israel?
Offer a very short reply. 0.48. What is the difference between the highest and the second highest Imports(as % of merchandise exports) of 1962?
Your answer should be very brief. 2.98. What is the difference between the highest and the second highest Imports(as % of merchandise exports) of 1963?
Make the answer very short. 2.44. What is the difference between the highest and the second highest Imports(as % of merchandise exports) of 1964?
Your response must be concise. 1.55. What is the difference between the highest and the second highest Imports(as % of merchandise exports) in 1965?
Offer a terse response. 0.86. What is the difference between the highest and the lowest Imports(as % of merchandise exports) in 1962?
Provide a short and direct response. 8.95. What is the difference between the highest and the lowest Imports(as % of merchandise exports) in 1963?
Offer a very short reply. 8.34. What is the difference between the highest and the lowest Imports(as % of merchandise exports) in 1964?
Give a very brief answer. 8.13. What is the difference between the highest and the lowest Imports(as % of merchandise exports) in 1965?
Keep it short and to the point. 6.72. 